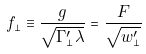Convert formula to latex. <formula><loc_0><loc_0><loc_500><loc_500>f _ { \perp } \equiv \frac { g } { \sqrt { \Gamma _ { \perp } ^ { \prime } \lambda } } = \frac { F } { \sqrt { w _ { \perp } ^ { \prime } } }</formula> 